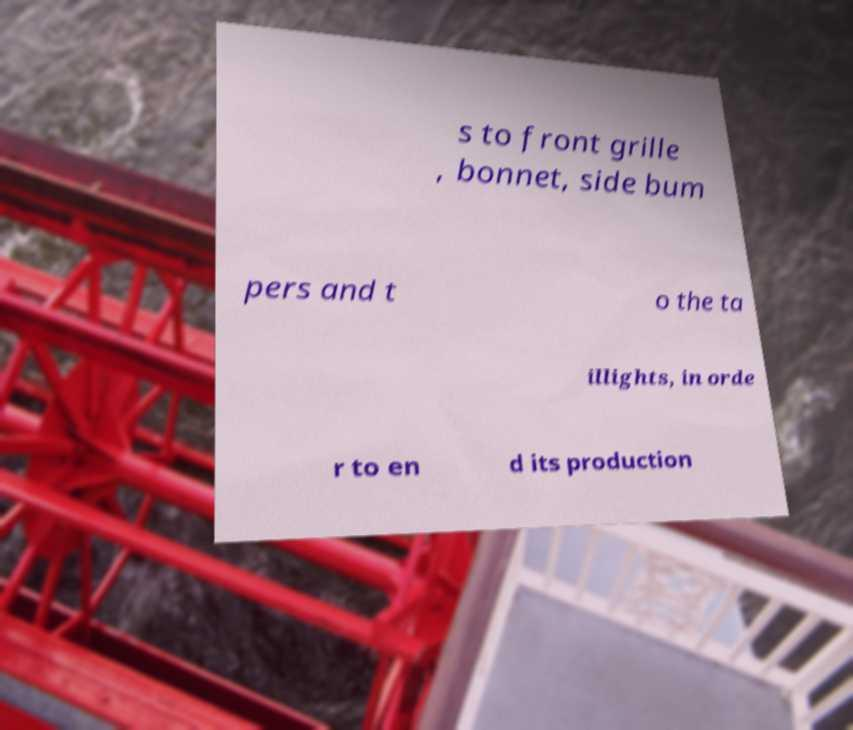Can you accurately transcribe the text from the provided image for me? s to front grille , bonnet, side bum pers and t o the ta illights, in orde r to en d its production 